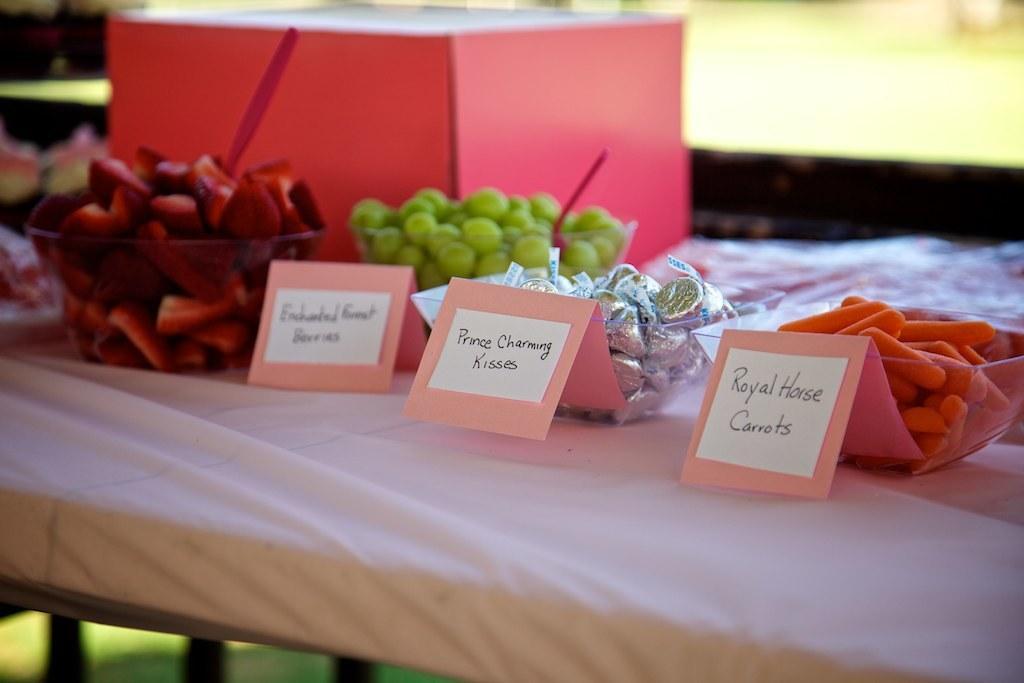In one or two sentences, can you explain what this image depicts? In this image we can see some cards with text and we can also see some food items placed on the surface. 